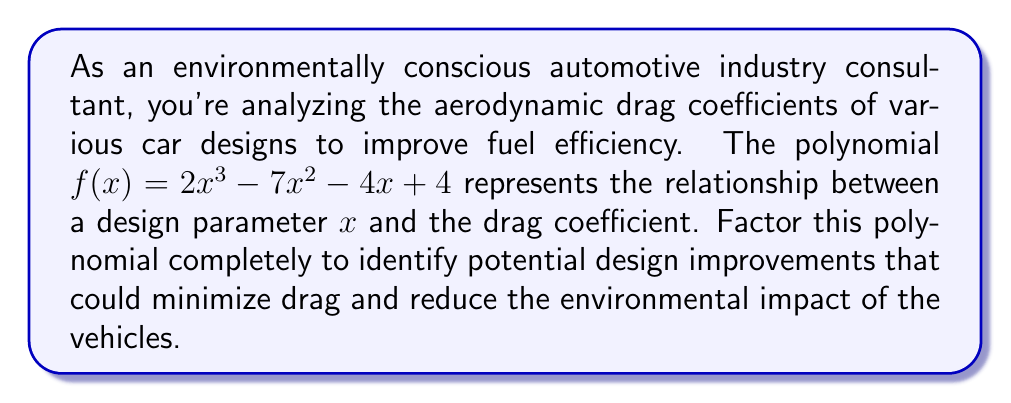Help me with this question. Let's approach this step-by-step:

1) First, we'll check if there are any common factors. In this case, there are none.

2) Next, we'll check if there are any rational roots using the rational root theorem. The possible rational roots are the factors of the constant term: ±1, ±2, ±4.

3) Testing these values, we find that $x = 1$ is a root of the polynomial.

4) We can factor out $(x - 1)$:

   $f(x) = (x - 1)(2x^2 - 5x - 4)$

5) Now we need to factor the quadratic term $2x^2 - 5x - 4$. We can do this by finding two numbers that multiply to give $2 \cdot (-4) = -8$ and add up to $-5$.

6) These numbers are $-8$ and $3$. So we can rewrite the quadratic as:

   $2x^2 - 8x + 3x - 4$

7) Grouping these terms:

   $2x(x - 4) + 1(3x - 4)$

8) Factoring out the common factor:

   $(2x + 1)(x - 4)$

9) Therefore, the complete factorization is:

   $f(x) = (x - 1)(2x + 1)(x - 4)$

This factorization reveals the design parameter values that result in zero drag coefficient: $x = 1$, $x = -\frac{1}{2}$, and $x = 4$. These points could represent critical design features that significantly affect the car's aerodynamics.
Answer: $f(x) = (x - 1)(2x + 1)(x - 4)$ 